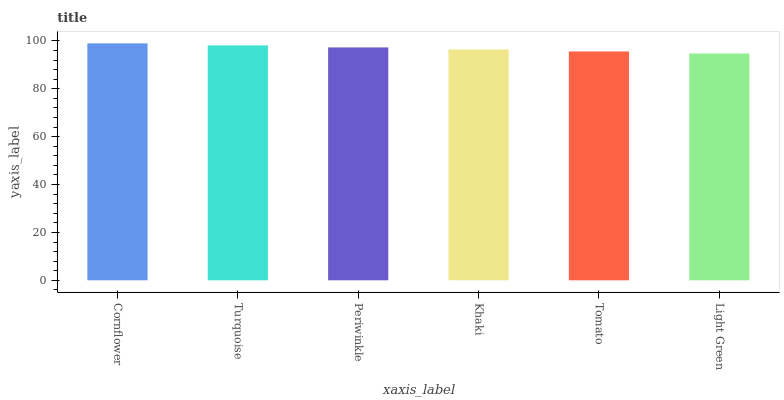Is Light Green the minimum?
Answer yes or no. Yes. Is Cornflower the maximum?
Answer yes or no. Yes. Is Turquoise the minimum?
Answer yes or no. No. Is Turquoise the maximum?
Answer yes or no. No. Is Cornflower greater than Turquoise?
Answer yes or no. Yes. Is Turquoise less than Cornflower?
Answer yes or no. Yes. Is Turquoise greater than Cornflower?
Answer yes or no. No. Is Cornflower less than Turquoise?
Answer yes or no. No. Is Periwinkle the high median?
Answer yes or no. Yes. Is Khaki the low median?
Answer yes or no. Yes. Is Khaki the high median?
Answer yes or no. No. Is Turquoise the low median?
Answer yes or no. No. 